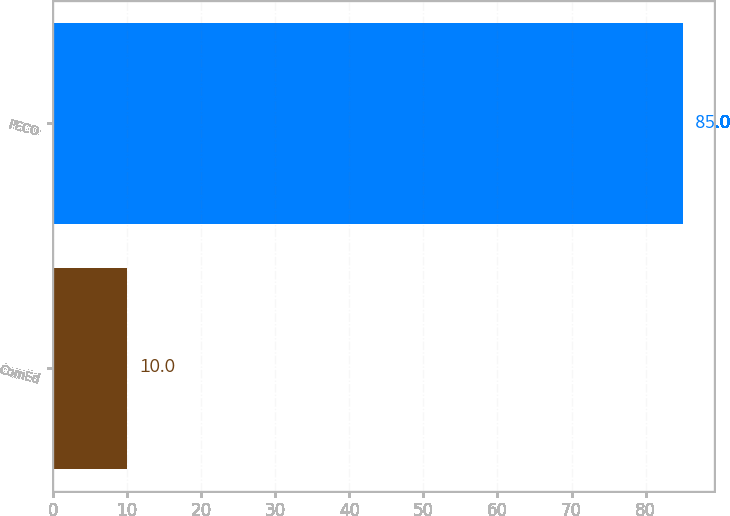<chart> <loc_0><loc_0><loc_500><loc_500><bar_chart><fcel>ComEd<fcel>PECO<nl><fcel>10<fcel>85<nl></chart> 